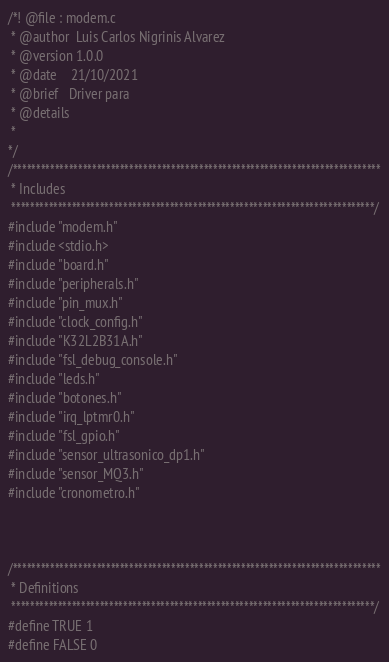<code> <loc_0><loc_0><loc_500><loc_500><_C_>/*! @file : modem.c
 * @author  Luis Carlos Nigrinis Alvarez
 * @version 1.0.0
 * @date    21/10/2021
 * @brief   Driver para 
 * @details
 *
*/
/*******************************************************************************
 * Includes
 ******************************************************************************/
#include "modem.h"
#include <stdio.h>
#include "board.h"
#include "peripherals.h"
#include "pin_mux.h"
#include "clock_config.h"
#include "K32L2B31A.h"
#include "fsl_debug_console.h"
#include "leds.h"
#include "botones.h"
#include "irq_lptmr0.h"
#include "fsl_gpio.h"
#include "sensor_ultrasonico_dp1.h"
#include "sensor_MQ3.h"
#include "cronometro.h"



/*******************************************************************************
 * Definitions
 ******************************************************************************/
#define TRUE 1
#define FALSE 0</code> 